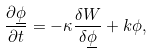Convert formula to latex. <formula><loc_0><loc_0><loc_500><loc_500>\frac { \partial \underline { \phi } } { \partial t } = - \kappa \frac { \delta W } { \delta \underline { \phi } } + k \phi ,</formula> 